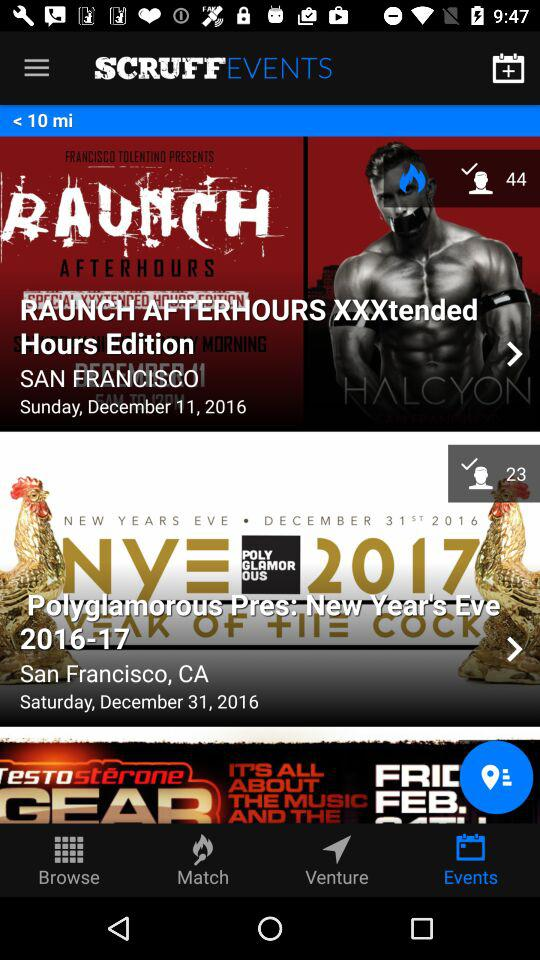What is the mentioned distance? The mentioned distance is less than 10 miles. 